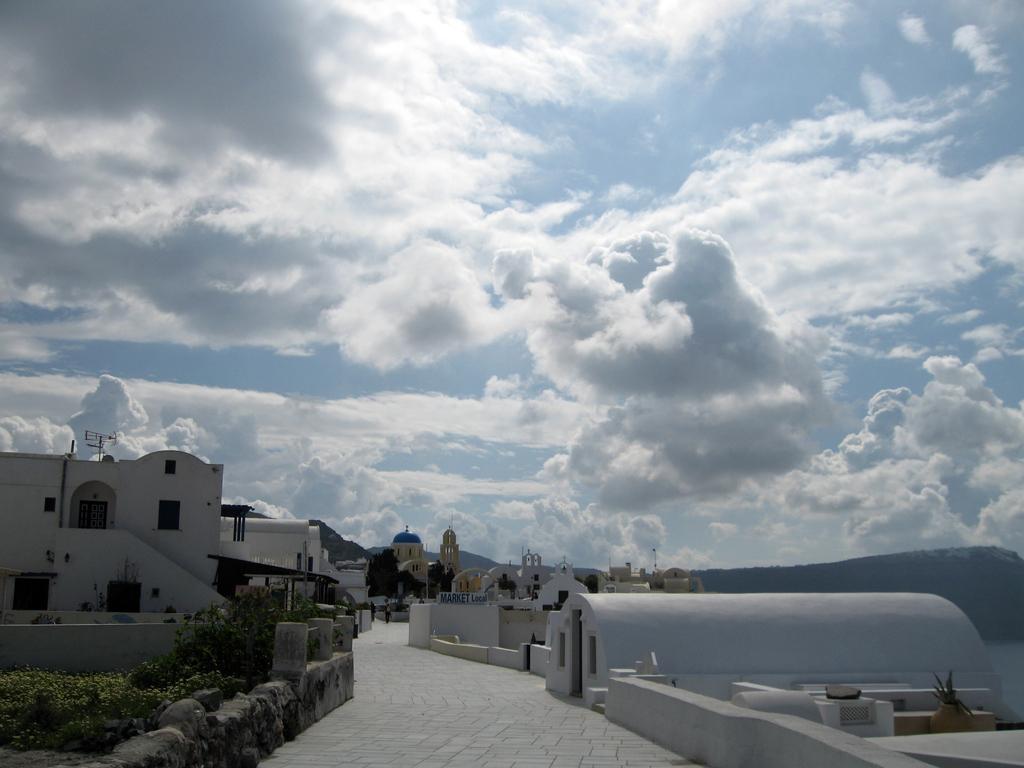Could you give a brief overview of what you see in this image? In this image there are houses, trees and bushes. On top of the houses there are antennas. In front of the houses there is pavement. At the top of the image there are clouds in the sky. In the background of the image there are mountains. 